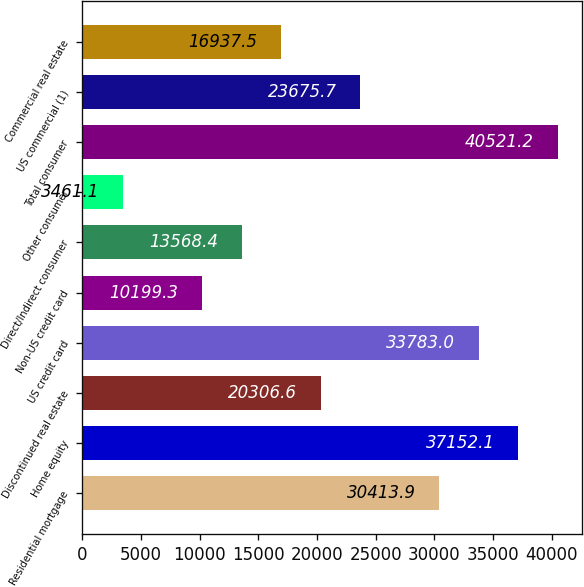Convert chart to OTSL. <chart><loc_0><loc_0><loc_500><loc_500><bar_chart><fcel>Residential mortgage<fcel>Home equity<fcel>Discontinued real estate<fcel>US credit card<fcel>Non-US credit card<fcel>Direct/Indirect consumer<fcel>Other consumer<fcel>Total consumer<fcel>US commercial (1)<fcel>Commercial real estate<nl><fcel>30413.9<fcel>37152.1<fcel>20306.6<fcel>33783<fcel>10199.3<fcel>13568.4<fcel>3461.1<fcel>40521.2<fcel>23675.7<fcel>16937.5<nl></chart> 